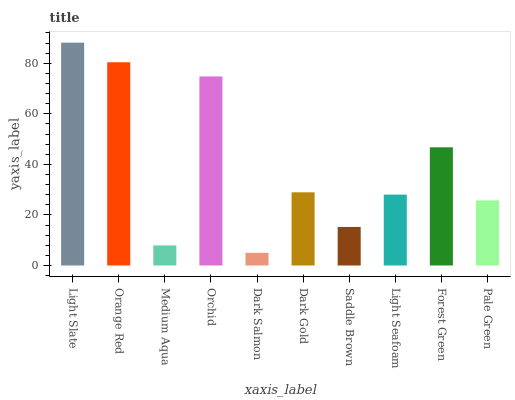Is Dark Salmon the minimum?
Answer yes or no. Yes. Is Light Slate the maximum?
Answer yes or no. Yes. Is Orange Red the minimum?
Answer yes or no. No. Is Orange Red the maximum?
Answer yes or no. No. Is Light Slate greater than Orange Red?
Answer yes or no. Yes. Is Orange Red less than Light Slate?
Answer yes or no. Yes. Is Orange Red greater than Light Slate?
Answer yes or no. No. Is Light Slate less than Orange Red?
Answer yes or no. No. Is Dark Gold the high median?
Answer yes or no. Yes. Is Light Seafoam the low median?
Answer yes or no. Yes. Is Light Slate the high median?
Answer yes or no. No. Is Orchid the low median?
Answer yes or no. No. 